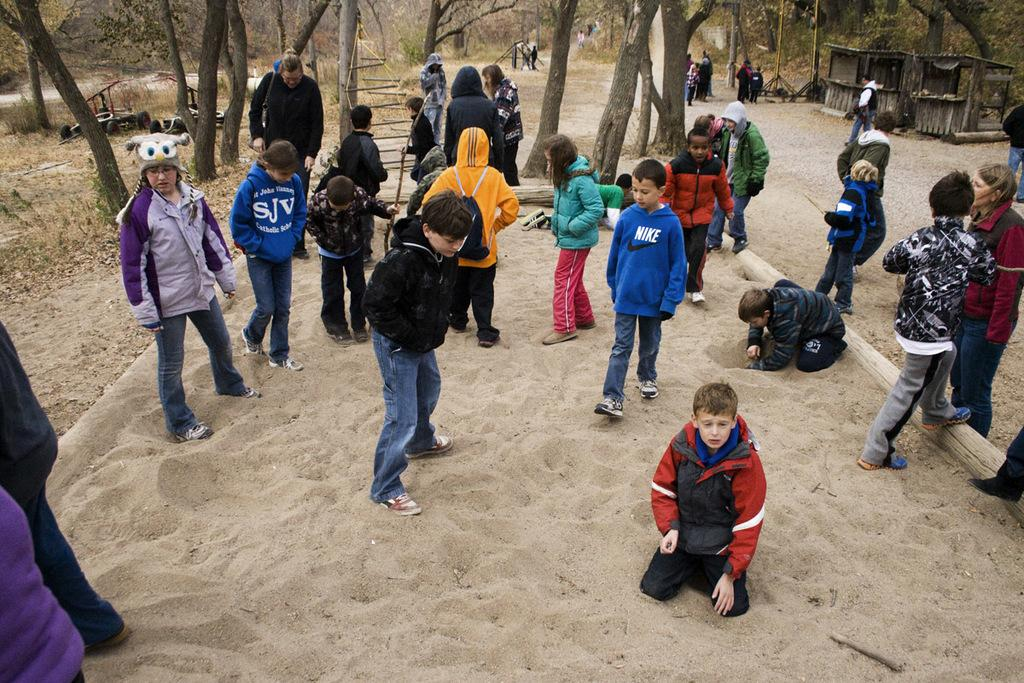How many people are in the image? There is a group of people standing in the image. What type of terrain is visible in the image? There is sand visible in the image. What type of structures can be seen in the image? There are wooden sheds in the image. What other objects are present in the image? There are tyres in the image. What can be seen in the background of the image? There are trees in the background of the image. What type of pets are playing with oranges in the image? There are no pets or oranges present in the image. 